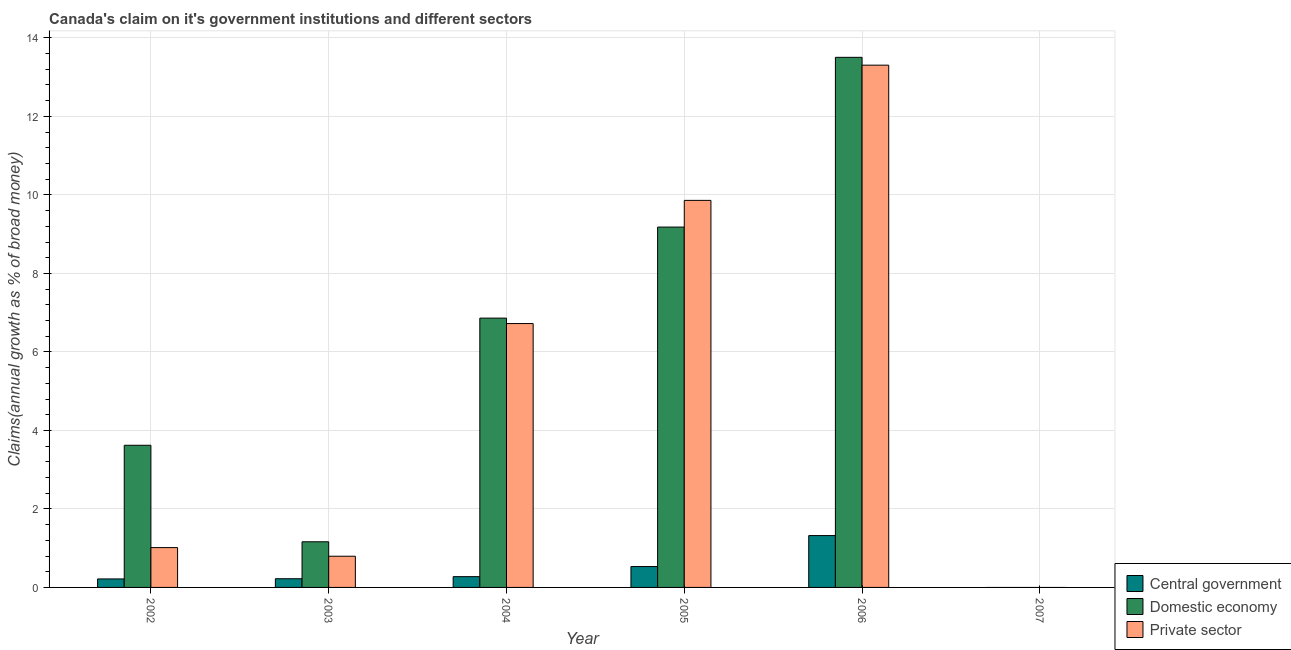How many different coloured bars are there?
Provide a short and direct response. 3. Are the number of bars on each tick of the X-axis equal?
Give a very brief answer. No. How many bars are there on the 5th tick from the left?
Keep it short and to the point. 3. How many bars are there on the 6th tick from the right?
Provide a succinct answer. 3. What is the label of the 5th group of bars from the left?
Give a very brief answer. 2006. What is the percentage of claim on the central government in 2007?
Provide a short and direct response. 0. Across all years, what is the maximum percentage of claim on the domestic economy?
Your response must be concise. 13.5. In which year was the percentage of claim on the private sector maximum?
Make the answer very short. 2006. What is the total percentage of claim on the central government in the graph?
Ensure brevity in your answer.  2.57. What is the difference between the percentage of claim on the central government in 2005 and that in 2006?
Give a very brief answer. -0.79. What is the difference between the percentage of claim on the central government in 2006 and the percentage of claim on the domestic economy in 2005?
Offer a very short reply. 0.79. What is the average percentage of claim on the private sector per year?
Keep it short and to the point. 5.28. In the year 2005, what is the difference between the percentage of claim on the central government and percentage of claim on the private sector?
Provide a short and direct response. 0. In how many years, is the percentage of claim on the domestic economy greater than 8.8 %?
Give a very brief answer. 2. What is the ratio of the percentage of claim on the central government in 2004 to that in 2005?
Offer a very short reply. 0.52. Is the percentage of claim on the domestic economy in 2002 less than that in 2003?
Provide a short and direct response. No. What is the difference between the highest and the second highest percentage of claim on the private sector?
Offer a terse response. 3.44. What is the difference between the highest and the lowest percentage of claim on the domestic economy?
Ensure brevity in your answer.  13.5. In how many years, is the percentage of claim on the domestic economy greater than the average percentage of claim on the domestic economy taken over all years?
Provide a succinct answer. 3. Are all the bars in the graph horizontal?
Offer a terse response. No. How many years are there in the graph?
Offer a very short reply. 6. What is the difference between two consecutive major ticks on the Y-axis?
Ensure brevity in your answer.  2. Are the values on the major ticks of Y-axis written in scientific E-notation?
Provide a succinct answer. No. Does the graph contain any zero values?
Give a very brief answer. Yes. Where does the legend appear in the graph?
Your response must be concise. Bottom right. How are the legend labels stacked?
Provide a succinct answer. Vertical. What is the title of the graph?
Offer a terse response. Canada's claim on it's government institutions and different sectors. Does "ICT services" appear as one of the legend labels in the graph?
Your answer should be compact. No. What is the label or title of the Y-axis?
Offer a very short reply. Claims(annual growth as % of broad money). What is the Claims(annual growth as % of broad money) in Central government in 2002?
Keep it short and to the point. 0.22. What is the Claims(annual growth as % of broad money) in Domestic economy in 2002?
Give a very brief answer. 3.62. What is the Claims(annual growth as % of broad money) in Private sector in 2002?
Provide a short and direct response. 1.01. What is the Claims(annual growth as % of broad money) of Central government in 2003?
Make the answer very short. 0.22. What is the Claims(annual growth as % of broad money) of Domestic economy in 2003?
Your answer should be compact. 1.16. What is the Claims(annual growth as % of broad money) of Private sector in 2003?
Your answer should be very brief. 0.79. What is the Claims(annual growth as % of broad money) in Central government in 2004?
Your answer should be compact. 0.27. What is the Claims(annual growth as % of broad money) of Domestic economy in 2004?
Make the answer very short. 6.86. What is the Claims(annual growth as % of broad money) of Private sector in 2004?
Offer a very short reply. 6.72. What is the Claims(annual growth as % of broad money) of Central government in 2005?
Give a very brief answer. 0.53. What is the Claims(annual growth as % of broad money) of Domestic economy in 2005?
Your answer should be very brief. 9.18. What is the Claims(annual growth as % of broad money) of Private sector in 2005?
Keep it short and to the point. 9.86. What is the Claims(annual growth as % of broad money) of Central government in 2006?
Your answer should be very brief. 1.32. What is the Claims(annual growth as % of broad money) of Domestic economy in 2006?
Your answer should be very brief. 13.5. What is the Claims(annual growth as % of broad money) of Private sector in 2006?
Give a very brief answer. 13.31. What is the Claims(annual growth as % of broad money) of Central government in 2007?
Ensure brevity in your answer.  0. What is the Claims(annual growth as % of broad money) in Domestic economy in 2007?
Your answer should be very brief. 0. What is the Claims(annual growth as % of broad money) in Private sector in 2007?
Your answer should be compact. 0. Across all years, what is the maximum Claims(annual growth as % of broad money) in Central government?
Keep it short and to the point. 1.32. Across all years, what is the maximum Claims(annual growth as % of broad money) in Domestic economy?
Provide a short and direct response. 13.5. Across all years, what is the maximum Claims(annual growth as % of broad money) in Private sector?
Provide a succinct answer. 13.31. Across all years, what is the minimum Claims(annual growth as % of broad money) of Central government?
Give a very brief answer. 0. Across all years, what is the minimum Claims(annual growth as % of broad money) of Domestic economy?
Offer a terse response. 0. Across all years, what is the minimum Claims(annual growth as % of broad money) in Private sector?
Offer a very short reply. 0. What is the total Claims(annual growth as % of broad money) in Central government in the graph?
Provide a short and direct response. 2.57. What is the total Claims(annual growth as % of broad money) of Domestic economy in the graph?
Your answer should be compact. 34.33. What is the total Claims(annual growth as % of broad money) in Private sector in the graph?
Keep it short and to the point. 31.7. What is the difference between the Claims(annual growth as % of broad money) in Central government in 2002 and that in 2003?
Offer a very short reply. -0.01. What is the difference between the Claims(annual growth as % of broad money) of Domestic economy in 2002 and that in 2003?
Provide a succinct answer. 2.46. What is the difference between the Claims(annual growth as % of broad money) in Private sector in 2002 and that in 2003?
Your answer should be compact. 0.22. What is the difference between the Claims(annual growth as % of broad money) of Central government in 2002 and that in 2004?
Provide a short and direct response. -0.06. What is the difference between the Claims(annual growth as % of broad money) in Domestic economy in 2002 and that in 2004?
Your response must be concise. -3.24. What is the difference between the Claims(annual growth as % of broad money) in Private sector in 2002 and that in 2004?
Your response must be concise. -5.71. What is the difference between the Claims(annual growth as % of broad money) of Central government in 2002 and that in 2005?
Offer a very short reply. -0.32. What is the difference between the Claims(annual growth as % of broad money) of Domestic economy in 2002 and that in 2005?
Your answer should be very brief. -5.56. What is the difference between the Claims(annual growth as % of broad money) of Private sector in 2002 and that in 2005?
Offer a terse response. -8.85. What is the difference between the Claims(annual growth as % of broad money) of Central government in 2002 and that in 2006?
Offer a very short reply. -1.1. What is the difference between the Claims(annual growth as % of broad money) of Domestic economy in 2002 and that in 2006?
Your answer should be very brief. -9.88. What is the difference between the Claims(annual growth as % of broad money) in Private sector in 2002 and that in 2006?
Give a very brief answer. -12.29. What is the difference between the Claims(annual growth as % of broad money) in Central government in 2003 and that in 2004?
Keep it short and to the point. -0.05. What is the difference between the Claims(annual growth as % of broad money) of Domestic economy in 2003 and that in 2004?
Keep it short and to the point. -5.7. What is the difference between the Claims(annual growth as % of broad money) of Private sector in 2003 and that in 2004?
Keep it short and to the point. -5.93. What is the difference between the Claims(annual growth as % of broad money) in Central government in 2003 and that in 2005?
Keep it short and to the point. -0.31. What is the difference between the Claims(annual growth as % of broad money) in Domestic economy in 2003 and that in 2005?
Offer a very short reply. -8.02. What is the difference between the Claims(annual growth as % of broad money) of Private sector in 2003 and that in 2005?
Your answer should be compact. -9.07. What is the difference between the Claims(annual growth as % of broad money) of Central government in 2003 and that in 2006?
Your answer should be compact. -1.1. What is the difference between the Claims(annual growth as % of broad money) in Domestic economy in 2003 and that in 2006?
Keep it short and to the point. -12.34. What is the difference between the Claims(annual growth as % of broad money) in Private sector in 2003 and that in 2006?
Your answer should be compact. -12.51. What is the difference between the Claims(annual growth as % of broad money) of Central government in 2004 and that in 2005?
Offer a terse response. -0.26. What is the difference between the Claims(annual growth as % of broad money) of Domestic economy in 2004 and that in 2005?
Offer a terse response. -2.32. What is the difference between the Claims(annual growth as % of broad money) in Private sector in 2004 and that in 2005?
Offer a very short reply. -3.14. What is the difference between the Claims(annual growth as % of broad money) in Central government in 2004 and that in 2006?
Keep it short and to the point. -1.05. What is the difference between the Claims(annual growth as % of broad money) of Domestic economy in 2004 and that in 2006?
Offer a very short reply. -6.64. What is the difference between the Claims(annual growth as % of broad money) in Private sector in 2004 and that in 2006?
Your response must be concise. -6.58. What is the difference between the Claims(annual growth as % of broad money) of Central government in 2005 and that in 2006?
Provide a short and direct response. -0.79. What is the difference between the Claims(annual growth as % of broad money) of Domestic economy in 2005 and that in 2006?
Your response must be concise. -4.32. What is the difference between the Claims(annual growth as % of broad money) of Private sector in 2005 and that in 2006?
Offer a terse response. -3.44. What is the difference between the Claims(annual growth as % of broad money) of Central government in 2002 and the Claims(annual growth as % of broad money) of Domestic economy in 2003?
Give a very brief answer. -0.95. What is the difference between the Claims(annual growth as % of broad money) in Central government in 2002 and the Claims(annual growth as % of broad money) in Private sector in 2003?
Provide a short and direct response. -0.58. What is the difference between the Claims(annual growth as % of broad money) in Domestic economy in 2002 and the Claims(annual growth as % of broad money) in Private sector in 2003?
Make the answer very short. 2.83. What is the difference between the Claims(annual growth as % of broad money) in Central government in 2002 and the Claims(annual growth as % of broad money) in Domestic economy in 2004?
Make the answer very short. -6.64. What is the difference between the Claims(annual growth as % of broad money) in Central government in 2002 and the Claims(annual growth as % of broad money) in Private sector in 2004?
Give a very brief answer. -6.51. What is the difference between the Claims(annual growth as % of broad money) of Domestic economy in 2002 and the Claims(annual growth as % of broad money) of Private sector in 2004?
Give a very brief answer. -3.1. What is the difference between the Claims(annual growth as % of broad money) of Central government in 2002 and the Claims(annual growth as % of broad money) of Domestic economy in 2005?
Offer a terse response. -8.96. What is the difference between the Claims(annual growth as % of broad money) of Central government in 2002 and the Claims(annual growth as % of broad money) of Private sector in 2005?
Offer a very short reply. -9.64. What is the difference between the Claims(annual growth as % of broad money) of Domestic economy in 2002 and the Claims(annual growth as % of broad money) of Private sector in 2005?
Keep it short and to the point. -6.24. What is the difference between the Claims(annual growth as % of broad money) of Central government in 2002 and the Claims(annual growth as % of broad money) of Domestic economy in 2006?
Give a very brief answer. -13.29. What is the difference between the Claims(annual growth as % of broad money) of Central government in 2002 and the Claims(annual growth as % of broad money) of Private sector in 2006?
Keep it short and to the point. -13.09. What is the difference between the Claims(annual growth as % of broad money) in Domestic economy in 2002 and the Claims(annual growth as % of broad money) in Private sector in 2006?
Offer a terse response. -9.68. What is the difference between the Claims(annual growth as % of broad money) in Central government in 2003 and the Claims(annual growth as % of broad money) in Domestic economy in 2004?
Offer a terse response. -6.64. What is the difference between the Claims(annual growth as % of broad money) of Central government in 2003 and the Claims(annual growth as % of broad money) of Private sector in 2004?
Provide a short and direct response. -6.5. What is the difference between the Claims(annual growth as % of broad money) in Domestic economy in 2003 and the Claims(annual growth as % of broad money) in Private sector in 2004?
Provide a short and direct response. -5.56. What is the difference between the Claims(annual growth as % of broad money) of Central government in 2003 and the Claims(annual growth as % of broad money) of Domestic economy in 2005?
Keep it short and to the point. -8.96. What is the difference between the Claims(annual growth as % of broad money) in Central government in 2003 and the Claims(annual growth as % of broad money) in Private sector in 2005?
Ensure brevity in your answer.  -9.64. What is the difference between the Claims(annual growth as % of broad money) in Domestic economy in 2003 and the Claims(annual growth as % of broad money) in Private sector in 2005?
Your response must be concise. -8.7. What is the difference between the Claims(annual growth as % of broad money) of Central government in 2003 and the Claims(annual growth as % of broad money) of Domestic economy in 2006?
Offer a very short reply. -13.28. What is the difference between the Claims(annual growth as % of broad money) in Central government in 2003 and the Claims(annual growth as % of broad money) in Private sector in 2006?
Offer a terse response. -13.08. What is the difference between the Claims(annual growth as % of broad money) of Domestic economy in 2003 and the Claims(annual growth as % of broad money) of Private sector in 2006?
Your answer should be compact. -12.14. What is the difference between the Claims(annual growth as % of broad money) in Central government in 2004 and the Claims(annual growth as % of broad money) in Domestic economy in 2005?
Ensure brevity in your answer.  -8.91. What is the difference between the Claims(annual growth as % of broad money) of Central government in 2004 and the Claims(annual growth as % of broad money) of Private sector in 2005?
Keep it short and to the point. -9.59. What is the difference between the Claims(annual growth as % of broad money) of Domestic economy in 2004 and the Claims(annual growth as % of broad money) of Private sector in 2005?
Provide a short and direct response. -3. What is the difference between the Claims(annual growth as % of broad money) of Central government in 2004 and the Claims(annual growth as % of broad money) of Domestic economy in 2006?
Provide a short and direct response. -13.23. What is the difference between the Claims(annual growth as % of broad money) in Central government in 2004 and the Claims(annual growth as % of broad money) in Private sector in 2006?
Offer a very short reply. -13.03. What is the difference between the Claims(annual growth as % of broad money) in Domestic economy in 2004 and the Claims(annual growth as % of broad money) in Private sector in 2006?
Provide a short and direct response. -6.44. What is the difference between the Claims(annual growth as % of broad money) in Central government in 2005 and the Claims(annual growth as % of broad money) in Domestic economy in 2006?
Offer a very short reply. -12.97. What is the difference between the Claims(annual growth as % of broad money) in Central government in 2005 and the Claims(annual growth as % of broad money) in Private sector in 2006?
Provide a succinct answer. -12.77. What is the difference between the Claims(annual growth as % of broad money) of Domestic economy in 2005 and the Claims(annual growth as % of broad money) of Private sector in 2006?
Your response must be concise. -4.12. What is the average Claims(annual growth as % of broad money) in Central government per year?
Keep it short and to the point. 0.43. What is the average Claims(annual growth as % of broad money) in Domestic economy per year?
Keep it short and to the point. 5.72. What is the average Claims(annual growth as % of broad money) of Private sector per year?
Your answer should be very brief. 5.28. In the year 2002, what is the difference between the Claims(annual growth as % of broad money) in Central government and Claims(annual growth as % of broad money) in Domestic economy?
Your answer should be very brief. -3.4. In the year 2002, what is the difference between the Claims(annual growth as % of broad money) in Central government and Claims(annual growth as % of broad money) in Private sector?
Offer a terse response. -0.8. In the year 2002, what is the difference between the Claims(annual growth as % of broad money) of Domestic economy and Claims(annual growth as % of broad money) of Private sector?
Your response must be concise. 2.61. In the year 2003, what is the difference between the Claims(annual growth as % of broad money) of Central government and Claims(annual growth as % of broad money) of Domestic economy?
Provide a short and direct response. -0.94. In the year 2003, what is the difference between the Claims(annual growth as % of broad money) in Central government and Claims(annual growth as % of broad money) in Private sector?
Your answer should be compact. -0.57. In the year 2003, what is the difference between the Claims(annual growth as % of broad money) in Domestic economy and Claims(annual growth as % of broad money) in Private sector?
Ensure brevity in your answer.  0.37. In the year 2004, what is the difference between the Claims(annual growth as % of broad money) of Central government and Claims(annual growth as % of broad money) of Domestic economy?
Offer a very short reply. -6.59. In the year 2004, what is the difference between the Claims(annual growth as % of broad money) of Central government and Claims(annual growth as % of broad money) of Private sector?
Provide a short and direct response. -6.45. In the year 2004, what is the difference between the Claims(annual growth as % of broad money) of Domestic economy and Claims(annual growth as % of broad money) of Private sector?
Offer a terse response. 0.14. In the year 2005, what is the difference between the Claims(annual growth as % of broad money) of Central government and Claims(annual growth as % of broad money) of Domestic economy?
Offer a very short reply. -8.65. In the year 2005, what is the difference between the Claims(annual growth as % of broad money) of Central government and Claims(annual growth as % of broad money) of Private sector?
Your response must be concise. -9.33. In the year 2005, what is the difference between the Claims(annual growth as % of broad money) of Domestic economy and Claims(annual growth as % of broad money) of Private sector?
Offer a terse response. -0.68. In the year 2006, what is the difference between the Claims(annual growth as % of broad money) of Central government and Claims(annual growth as % of broad money) of Domestic economy?
Give a very brief answer. -12.18. In the year 2006, what is the difference between the Claims(annual growth as % of broad money) of Central government and Claims(annual growth as % of broad money) of Private sector?
Your answer should be very brief. -11.98. In the year 2006, what is the difference between the Claims(annual growth as % of broad money) in Domestic economy and Claims(annual growth as % of broad money) in Private sector?
Ensure brevity in your answer.  0.2. What is the ratio of the Claims(annual growth as % of broad money) of Central government in 2002 to that in 2003?
Your answer should be compact. 0.98. What is the ratio of the Claims(annual growth as % of broad money) in Domestic economy in 2002 to that in 2003?
Keep it short and to the point. 3.11. What is the ratio of the Claims(annual growth as % of broad money) of Private sector in 2002 to that in 2003?
Provide a short and direct response. 1.28. What is the ratio of the Claims(annual growth as % of broad money) of Central government in 2002 to that in 2004?
Provide a short and direct response. 0.79. What is the ratio of the Claims(annual growth as % of broad money) of Domestic economy in 2002 to that in 2004?
Offer a terse response. 0.53. What is the ratio of the Claims(annual growth as % of broad money) in Private sector in 2002 to that in 2004?
Ensure brevity in your answer.  0.15. What is the ratio of the Claims(annual growth as % of broad money) in Central government in 2002 to that in 2005?
Offer a terse response. 0.41. What is the ratio of the Claims(annual growth as % of broad money) in Domestic economy in 2002 to that in 2005?
Offer a terse response. 0.39. What is the ratio of the Claims(annual growth as % of broad money) in Private sector in 2002 to that in 2005?
Provide a short and direct response. 0.1. What is the ratio of the Claims(annual growth as % of broad money) of Central government in 2002 to that in 2006?
Provide a succinct answer. 0.16. What is the ratio of the Claims(annual growth as % of broad money) of Domestic economy in 2002 to that in 2006?
Offer a very short reply. 0.27. What is the ratio of the Claims(annual growth as % of broad money) of Private sector in 2002 to that in 2006?
Offer a terse response. 0.08. What is the ratio of the Claims(annual growth as % of broad money) in Central government in 2003 to that in 2004?
Your answer should be very brief. 0.81. What is the ratio of the Claims(annual growth as % of broad money) of Domestic economy in 2003 to that in 2004?
Provide a succinct answer. 0.17. What is the ratio of the Claims(annual growth as % of broad money) in Private sector in 2003 to that in 2004?
Your response must be concise. 0.12. What is the ratio of the Claims(annual growth as % of broad money) in Central government in 2003 to that in 2005?
Give a very brief answer. 0.42. What is the ratio of the Claims(annual growth as % of broad money) in Domestic economy in 2003 to that in 2005?
Offer a terse response. 0.13. What is the ratio of the Claims(annual growth as % of broad money) in Private sector in 2003 to that in 2005?
Keep it short and to the point. 0.08. What is the ratio of the Claims(annual growth as % of broad money) in Central government in 2003 to that in 2006?
Provide a succinct answer. 0.17. What is the ratio of the Claims(annual growth as % of broad money) of Domestic economy in 2003 to that in 2006?
Provide a succinct answer. 0.09. What is the ratio of the Claims(annual growth as % of broad money) in Private sector in 2003 to that in 2006?
Your response must be concise. 0.06. What is the ratio of the Claims(annual growth as % of broad money) in Central government in 2004 to that in 2005?
Make the answer very short. 0.52. What is the ratio of the Claims(annual growth as % of broad money) of Domestic economy in 2004 to that in 2005?
Your answer should be compact. 0.75. What is the ratio of the Claims(annual growth as % of broad money) of Private sector in 2004 to that in 2005?
Provide a short and direct response. 0.68. What is the ratio of the Claims(annual growth as % of broad money) in Central government in 2004 to that in 2006?
Keep it short and to the point. 0.21. What is the ratio of the Claims(annual growth as % of broad money) in Domestic economy in 2004 to that in 2006?
Provide a succinct answer. 0.51. What is the ratio of the Claims(annual growth as % of broad money) of Private sector in 2004 to that in 2006?
Provide a succinct answer. 0.51. What is the ratio of the Claims(annual growth as % of broad money) in Central government in 2005 to that in 2006?
Your answer should be very brief. 0.4. What is the ratio of the Claims(annual growth as % of broad money) of Domestic economy in 2005 to that in 2006?
Offer a very short reply. 0.68. What is the ratio of the Claims(annual growth as % of broad money) of Private sector in 2005 to that in 2006?
Keep it short and to the point. 0.74. What is the difference between the highest and the second highest Claims(annual growth as % of broad money) in Central government?
Keep it short and to the point. 0.79. What is the difference between the highest and the second highest Claims(annual growth as % of broad money) of Domestic economy?
Your response must be concise. 4.32. What is the difference between the highest and the second highest Claims(annual growth as % of broad money) of Private sector?
Provide a short and direct response. 3.44. What is the difference between the highest and the lowest Claims(annual growth as % of broad money) in Central government?
Make the answer very short. 1.32. What is the difference between the highest and the lowest Claims(annual growth as % of broad money) in Domestic economy?
Ensure brevity in your answer.  13.5. What is the difference between the highest and the lowest Claims(annual growth as % of broad money) of Private sector?
Your answer should be very brief. 13.3. 